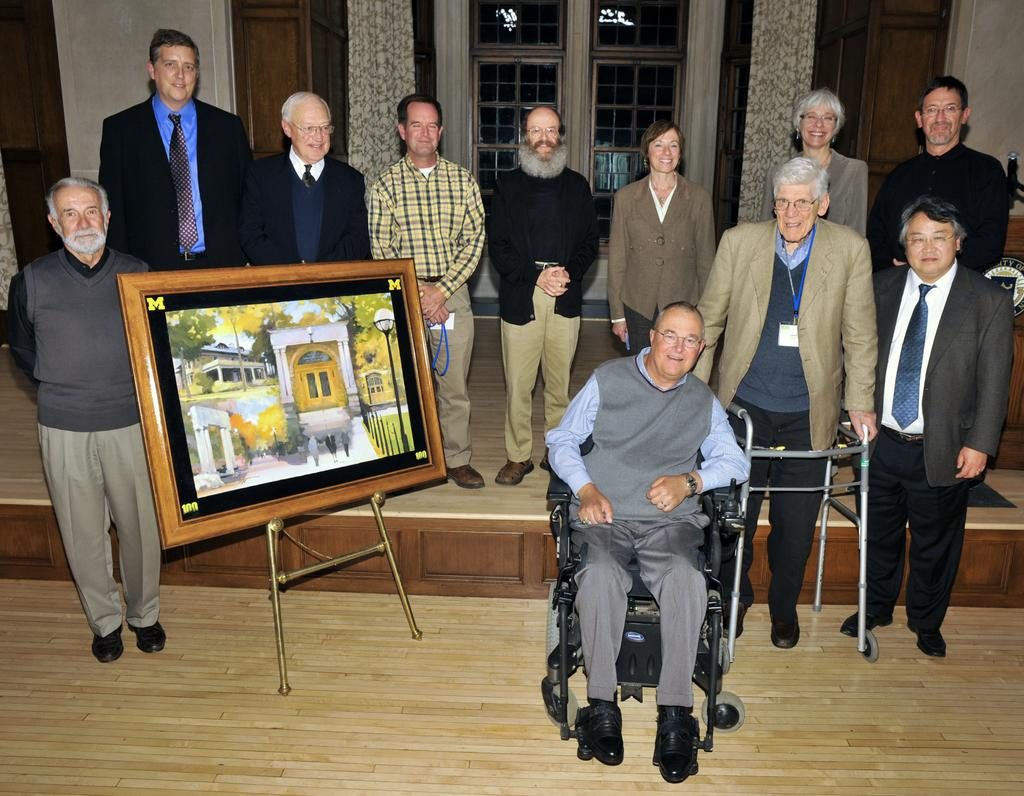How many people are in the image? There is a group of people in the image. What are the people in the image doing? The people are on the ground. Can you describe the person in the wheelchair? There is a person sitting in a wheelchair. What can be seen in the background of the image? There is a wall, doors, and curtains in the background of the image. What type of umbrella is being used to rake leaves in the image? There is no umbrella or rake present in the image. How many times does the person in the wheelchair rub their hands together in the image? There is no indication of hand-rubbing in the image. 